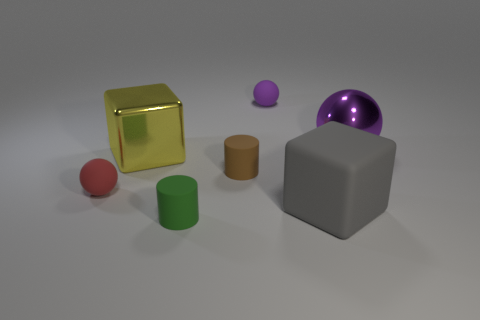Add 1 big gray shiny spheres. How many objects exist? 8 Subtract all spheres. How many objects are left? 4 Subtract 0 purple cubes. How many objects are left? 7 Subtract all small rubber things. Subtract all large gray metallic cubes. How many objects are left? 3 Add 1 tiny purple spheres. How many tiny purple spheres are left? 2 Add 1 matte cubes. How many matte cubes exist? 2 